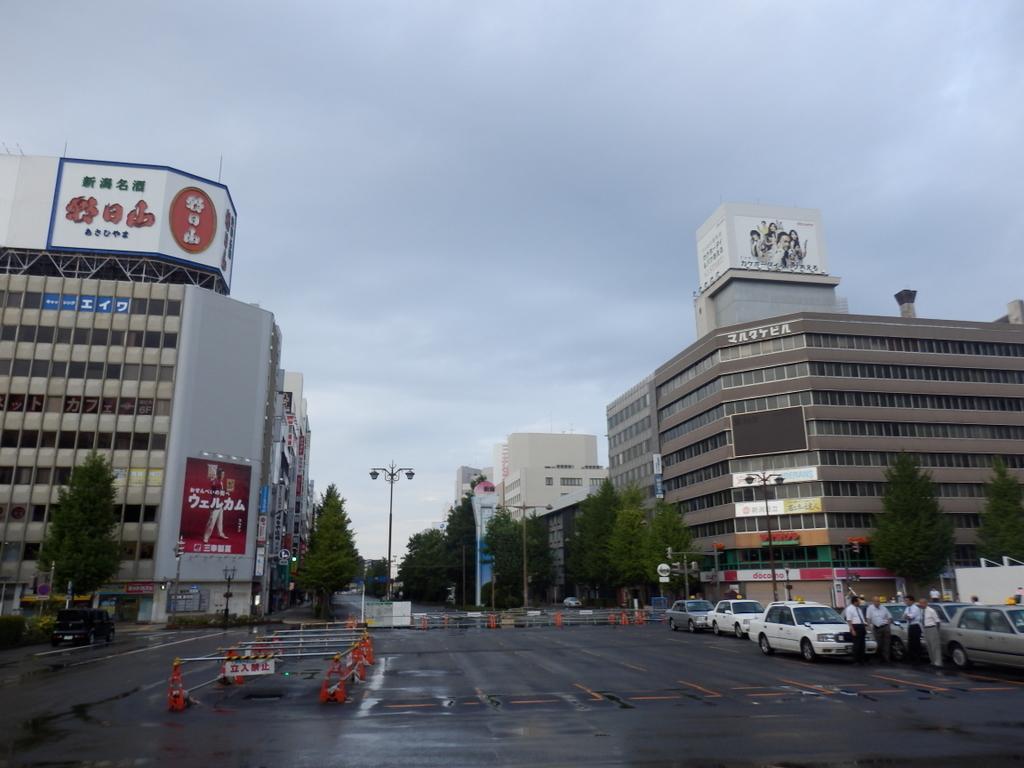Can you describe this image briefly? In this image there is a road, on that road there are cars and persons are standing, in the background there are buildings, trees, poles, at the top of the building, there are hoardings on that hoardings there is some text and pictures and there is the sky. 